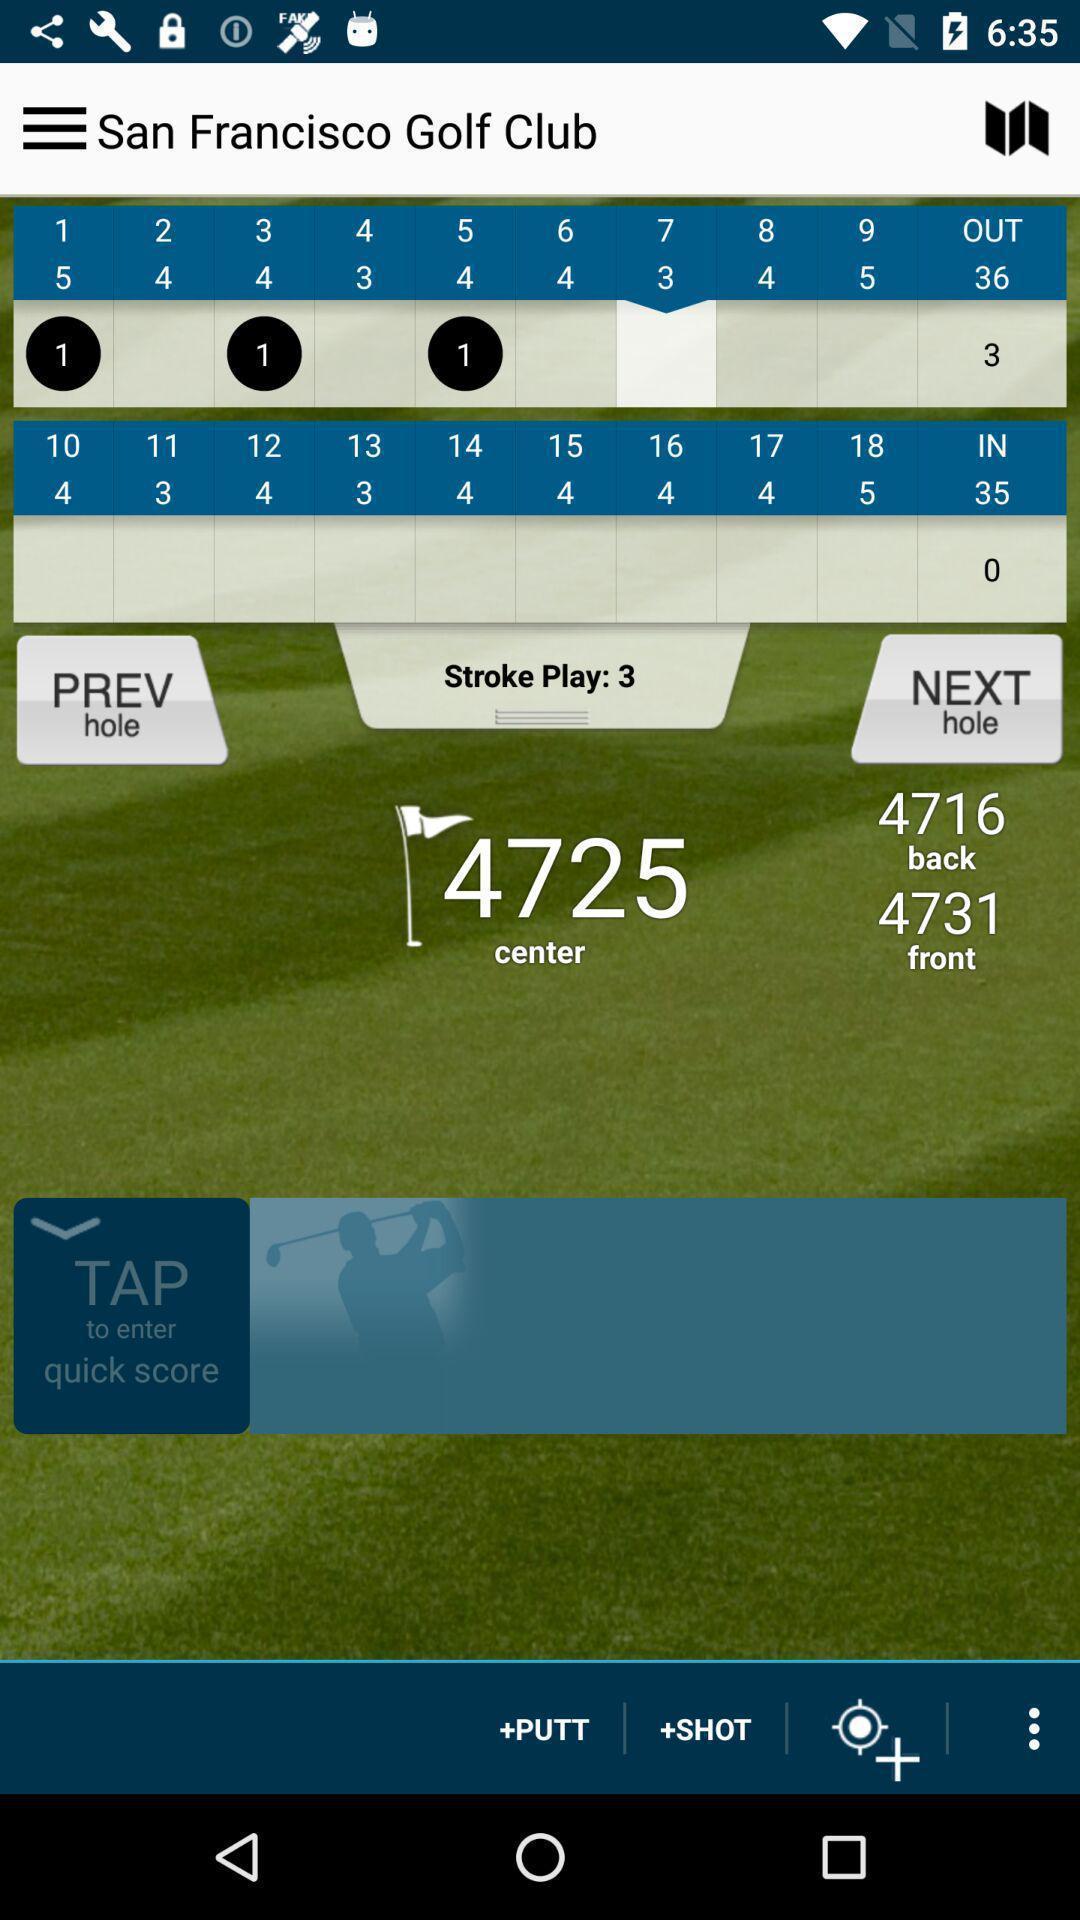Give me a narrative description of this picture. Sports app showing the game score details. 